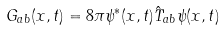Convert formula to latex. <formula><loc_0><loc_0><loc_500><loc_500>G _ { a b } ( x , t ) = 8 \pi \psi ^ { * } ( x , t ) \hat { T } _ { a b } \psi ( x , t )</formula> 